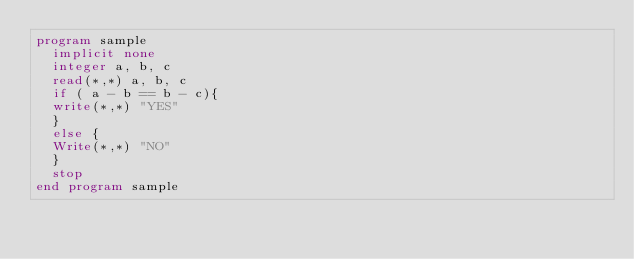<code> <loc_0><loc_0><loc_500><loc_500><_FORTRAN_>program sample
  implicit none
  integer a, b, c
  read(*,*) a, b, c
  if ( a - b == b - c){
  write(*,*) "YES"
  }
  else {
  Write(*,*) "NO"
  }
  stop
end program sample 
 </code> 